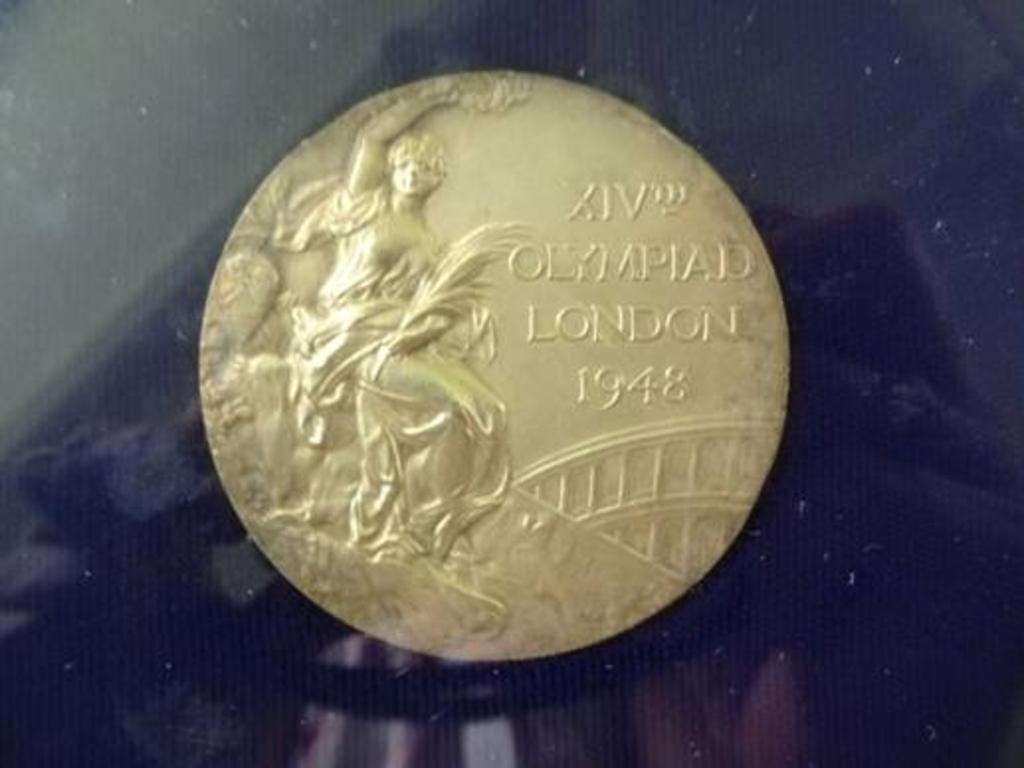<image>
Share a concise interpretation of the image provided. A coin with Olympiad London 1948 engraved on it. 